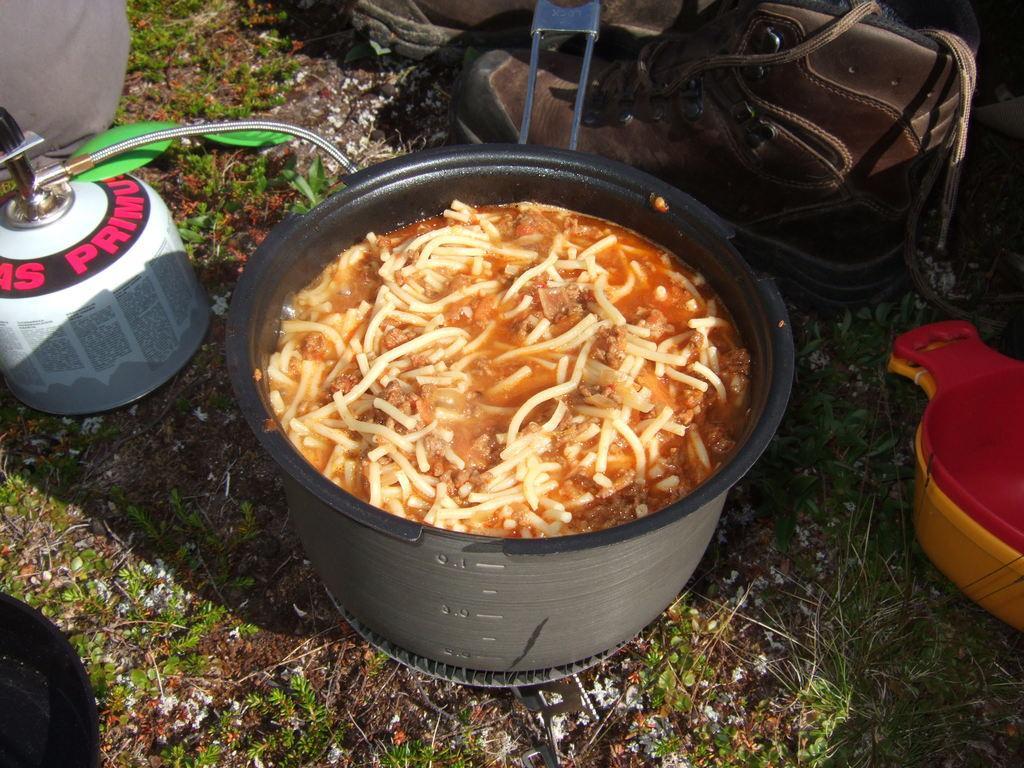How would you summarize this image in a sentence or two? In this image we can see a food item in a vessel. To the left side of the image there is a gas cylinder. To the right side of the image there is a plastic box. In the background of the image there is a shoe. At the bottom of the image there is grass and soil. 